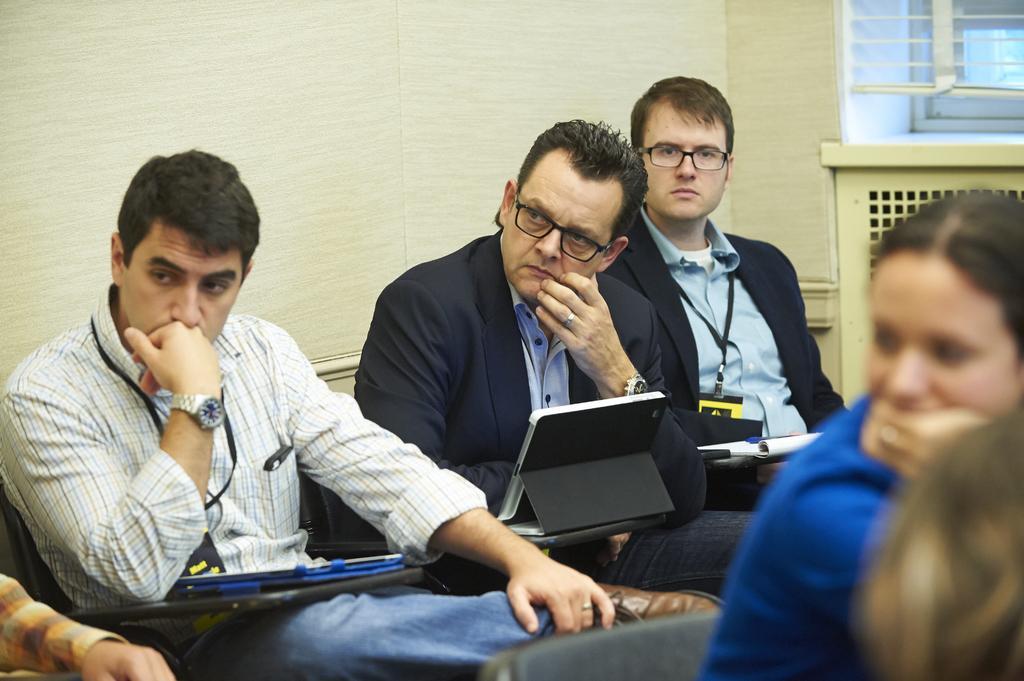Could you give a brief overview of what you see in this image? In the picture we can see three men are sitting on the bench near the wall, the two men are in black color blazer and holding laptops and one man is in shirt and keeping his hand near his mouth and in front of them, we can see a woman sitting and she in blue color shirt and in the background we can see a wall and a window with a glass to it. 